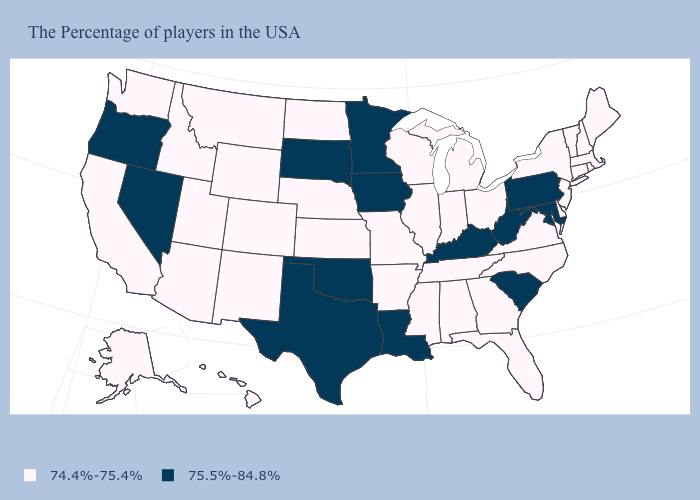Name the states that have a value in the range 74.4%-75.4%?
Answer briefly. Maine, Massachusetts, Rhode Island, New Hampshire, Vermont, Connecticut, New York, New Jersey, Delaware, Virginia, North Carolina, Ohio, Florida, Georgia, Michigan, Indiana, Alabama, Tennessee, Wisconsin, Illinois, Mississippi, Missouri, Arkansas, Kansas, Nebraska, North Dakota, Wyoming, Colorado, New Mexico, Utah, Montana, Arizona, Idaho, California, Washington, Alaska, Hawaii. Does the map have missing data?
Write a very short answer. No. Which states hav the highest value in the West?
Write a very short answer. Nevada, Oregon. Does South Carolina have the same value as Maine?
Answer briefly. No. Which states hav the highest value in the MidWest?
Be succinct. Minnesota, Iowa, South Dakota. How many symbols are there in the legend?
Write a very short answer. 2. What is the lowest value in the South?
Concise answer only. 74.4%-75.4%. Name the states that have a value in the range 74.4%-75.4%?
Give a very brief answer. Maine, Massachusetts, Rhode Island, New Hampshire, Vermont, Connecticut, New York, New Jersey, Delaware, Virginia, North Carolina, Ohio, Florida, Georgia, Michigan, Indiana, Alabama, Tennessee, Wisconsin, Illinois, Mississippi, Missouri, Arkansas, Kansas, Nebraska, North Dakota, Wyoming, Colorado, New Mexico, Utah, Montana, Arizona, Idaho, California, Washington, Alaska, Hawaii. Name the states that have a value in the range 74.4%-75.4%?
Give a very brief answer. Maine, Massachusetts, Rhode Island, New Hampshire, Vermont, Connecticut, New York, New Jersey, Delaware, Virginia, North Carolina, Ohio, Florida, Georgia, Michigan, Indiana, Alabama, Tennessee, Wisconsin, Illinois, Mississippi, Missouri, Arkansas, Kansas, Nebraska, North Dakota, Wyoming, Colorado, New Mexico, Utah, Montana, Arizona, Idaho, California, Washington, Alaska, Hawaii. Name the states that have a value in the range 75.5%-84.8%?
Give a very brief answer. Maryland, Pennsylvania, South Carolina, West Virginia, Kentucky, Louisiana, Minnesota, Iowa, Oklahoma, Texas, South Dakota, Nevada, Oregon. Name the states that have a value in the range 75.5%-84.8%?
Write a very short answer. Maryland, Pennsylvania, South Carolina, West Virginia, Kentucky, Louisiana, Minnesota, Iowa, Oklahoma, Texas, South Dakota, Nevada, Oregon. Among the states that border Louisiana , which have the highest value?
Keep it brief. Texas. Among the states that border Texas , which have the lowest value?
Be succinct. Arkansas, New Mexico. What is the value of Pennsylvania?
Keep it brief. 75.5%-84.8%. Does Rhode Island have a higher value than Maryland?
Be succinct. No. 